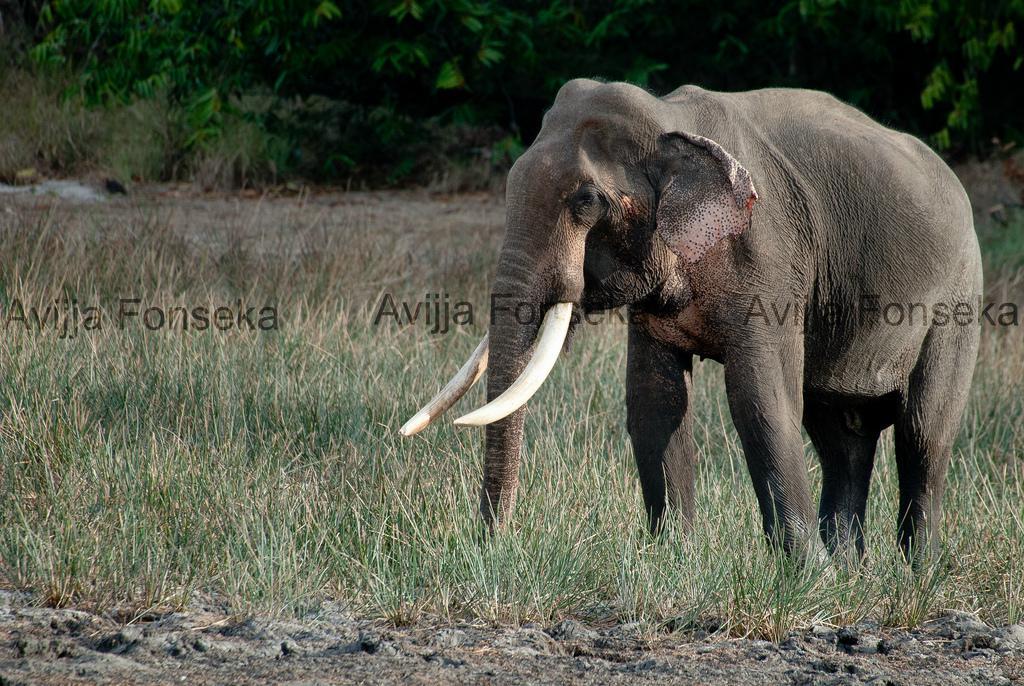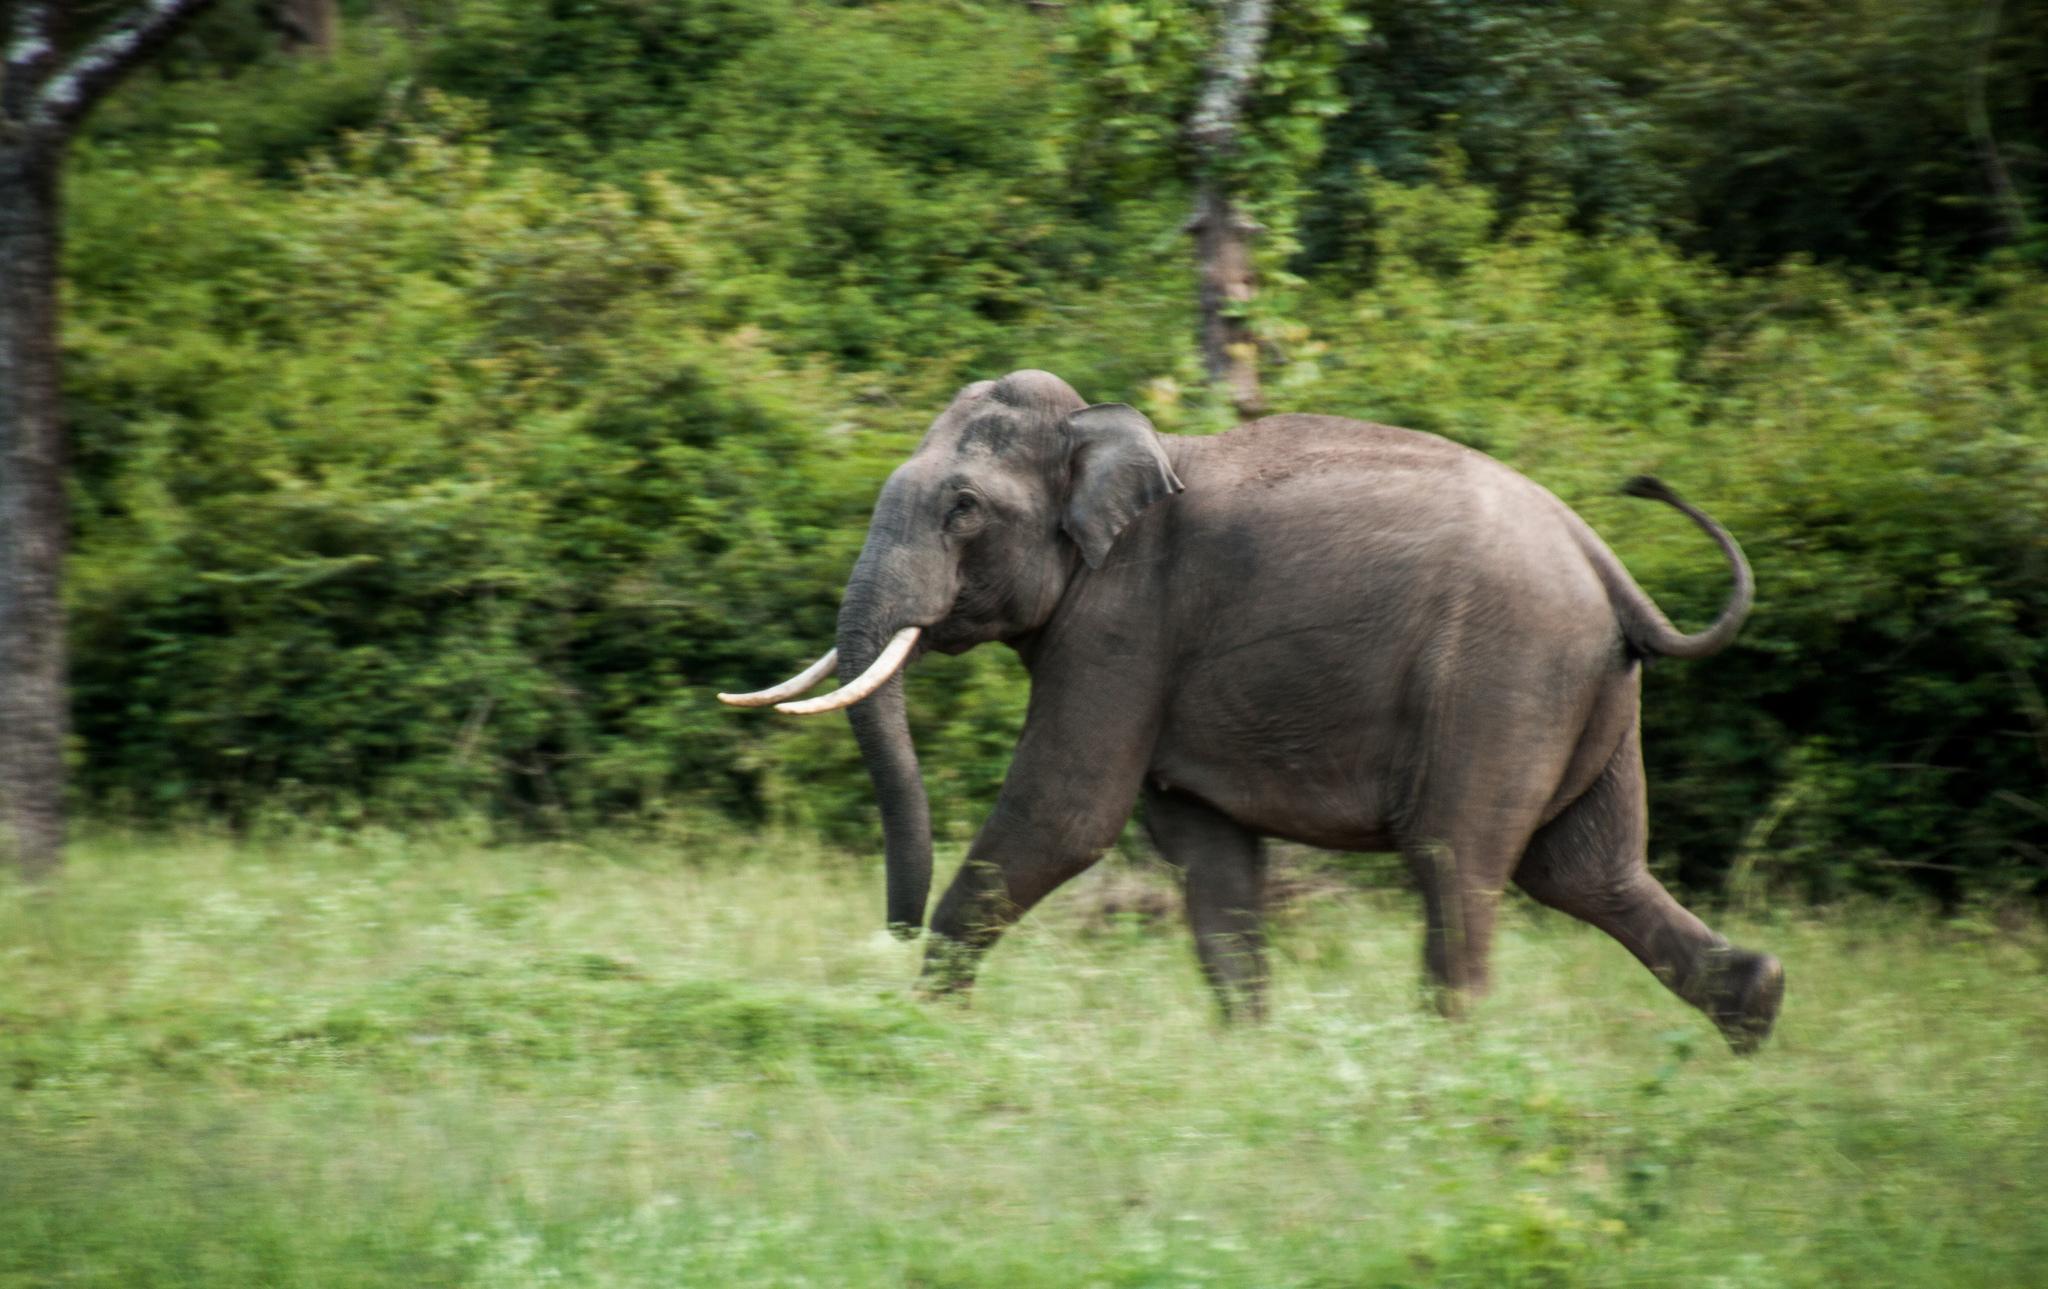The first image is the image on the left, the second image is the image on the right. Considering the images on both sides, is "All elephants have ivory tusks." valid? Answer yes or no. Yes. 